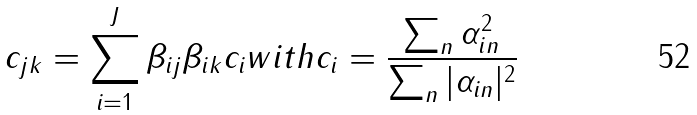<formula> <loc_0><loc_0><loc_500><loc_500>c _ { j k } = \sum _ { i = 1 } ^ { J } \beta _ { i j } \beta _ { i k } c _ { i } w i t h c _ { i } = \frac { \sum _ { n } \alpha _ { i n } ^ { 2 } } { \sum _ { n } | \alpha _ { i n } | ^ { 2 } }</formula> 